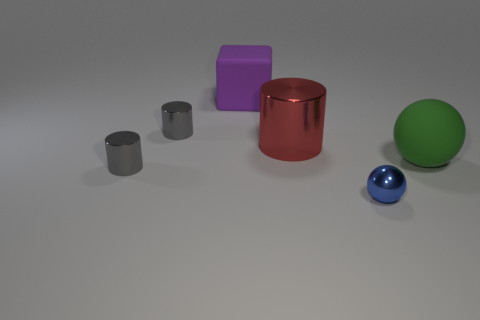Add 2 small purple metallic things. How many objects exist? 8 Subtract all blocks. How many objects are left? 5 Add 3 rubber blocks. How many rubber blocks exist? 4 Subtract 0 brown balls. How many objects are left? 6 Subtract all tiny cyan matte cylinders. Subtract all red things. How many objects are left? 5 Add 3 rubber things. How many rubber things are left? 5 